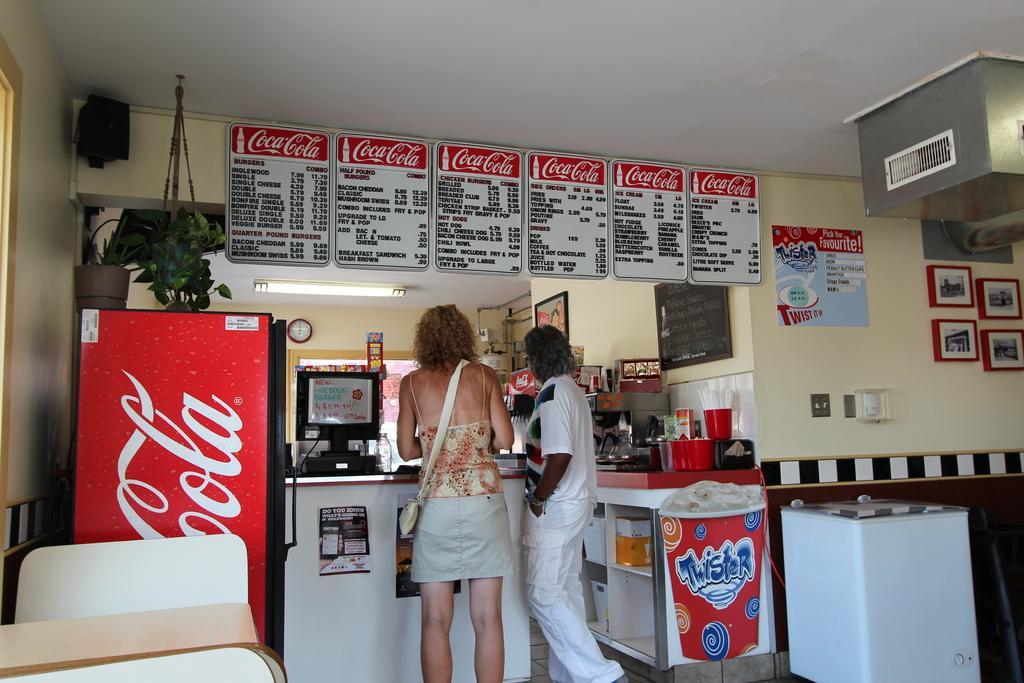Please provide a concise description of this image. In this picture there is a woman and a man standing in the bakery. Above there are some menu cards. In the front we can see the black computer, red color refrigerator. On the right side there is a white color refrigerator. Behind there is a yellow color wall with some photo frames and ac vent. 